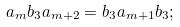<formula> <loc_0><loc_0><loc_500><loc_500>a _ { m } b _ { 3 } a _ { m + 2 } = b _ { 3 } a _ { m + 1 } b _ { 3 } ;</formula> 